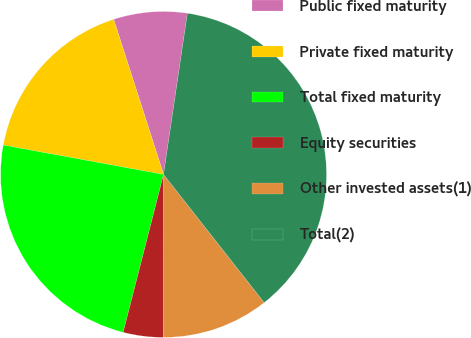Convert chart to OTSL. <chart><loc_0><loc_0><loc_500><loc_500><pie_chart><fcel>Public fixed maturity<fcel>Private fixed maturity<fcel>Total fixed maturity<fcel>Equity securities<fcel>Other invested assets(1)<fcel>Total(2)<nl><fcel>7.29%<fcel>17.16%<fcel>23.9%<fcel>3.98%<fcel>10.6%<fcel>37.07%<nl></chart> 